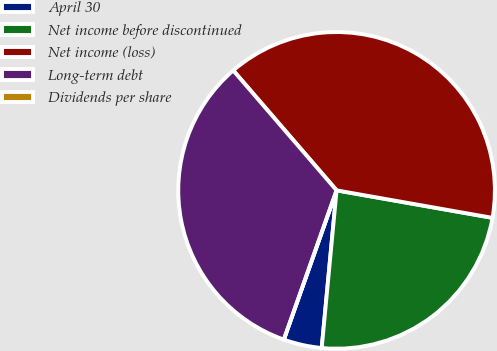Convert chart. <chart><loc_0><loc_0><loc_500><loc_500><pie_chart><fcel>April 30<fcel>Net income before discontinued<fcel>Net income (loss)<fcel>Long-term debt<fcel>Dividends per share<nl><fcel>3.91%<fcel>23.72%<fcel>39.1%<fcel>33.27%<fcel>0.0%<nl></chart> 